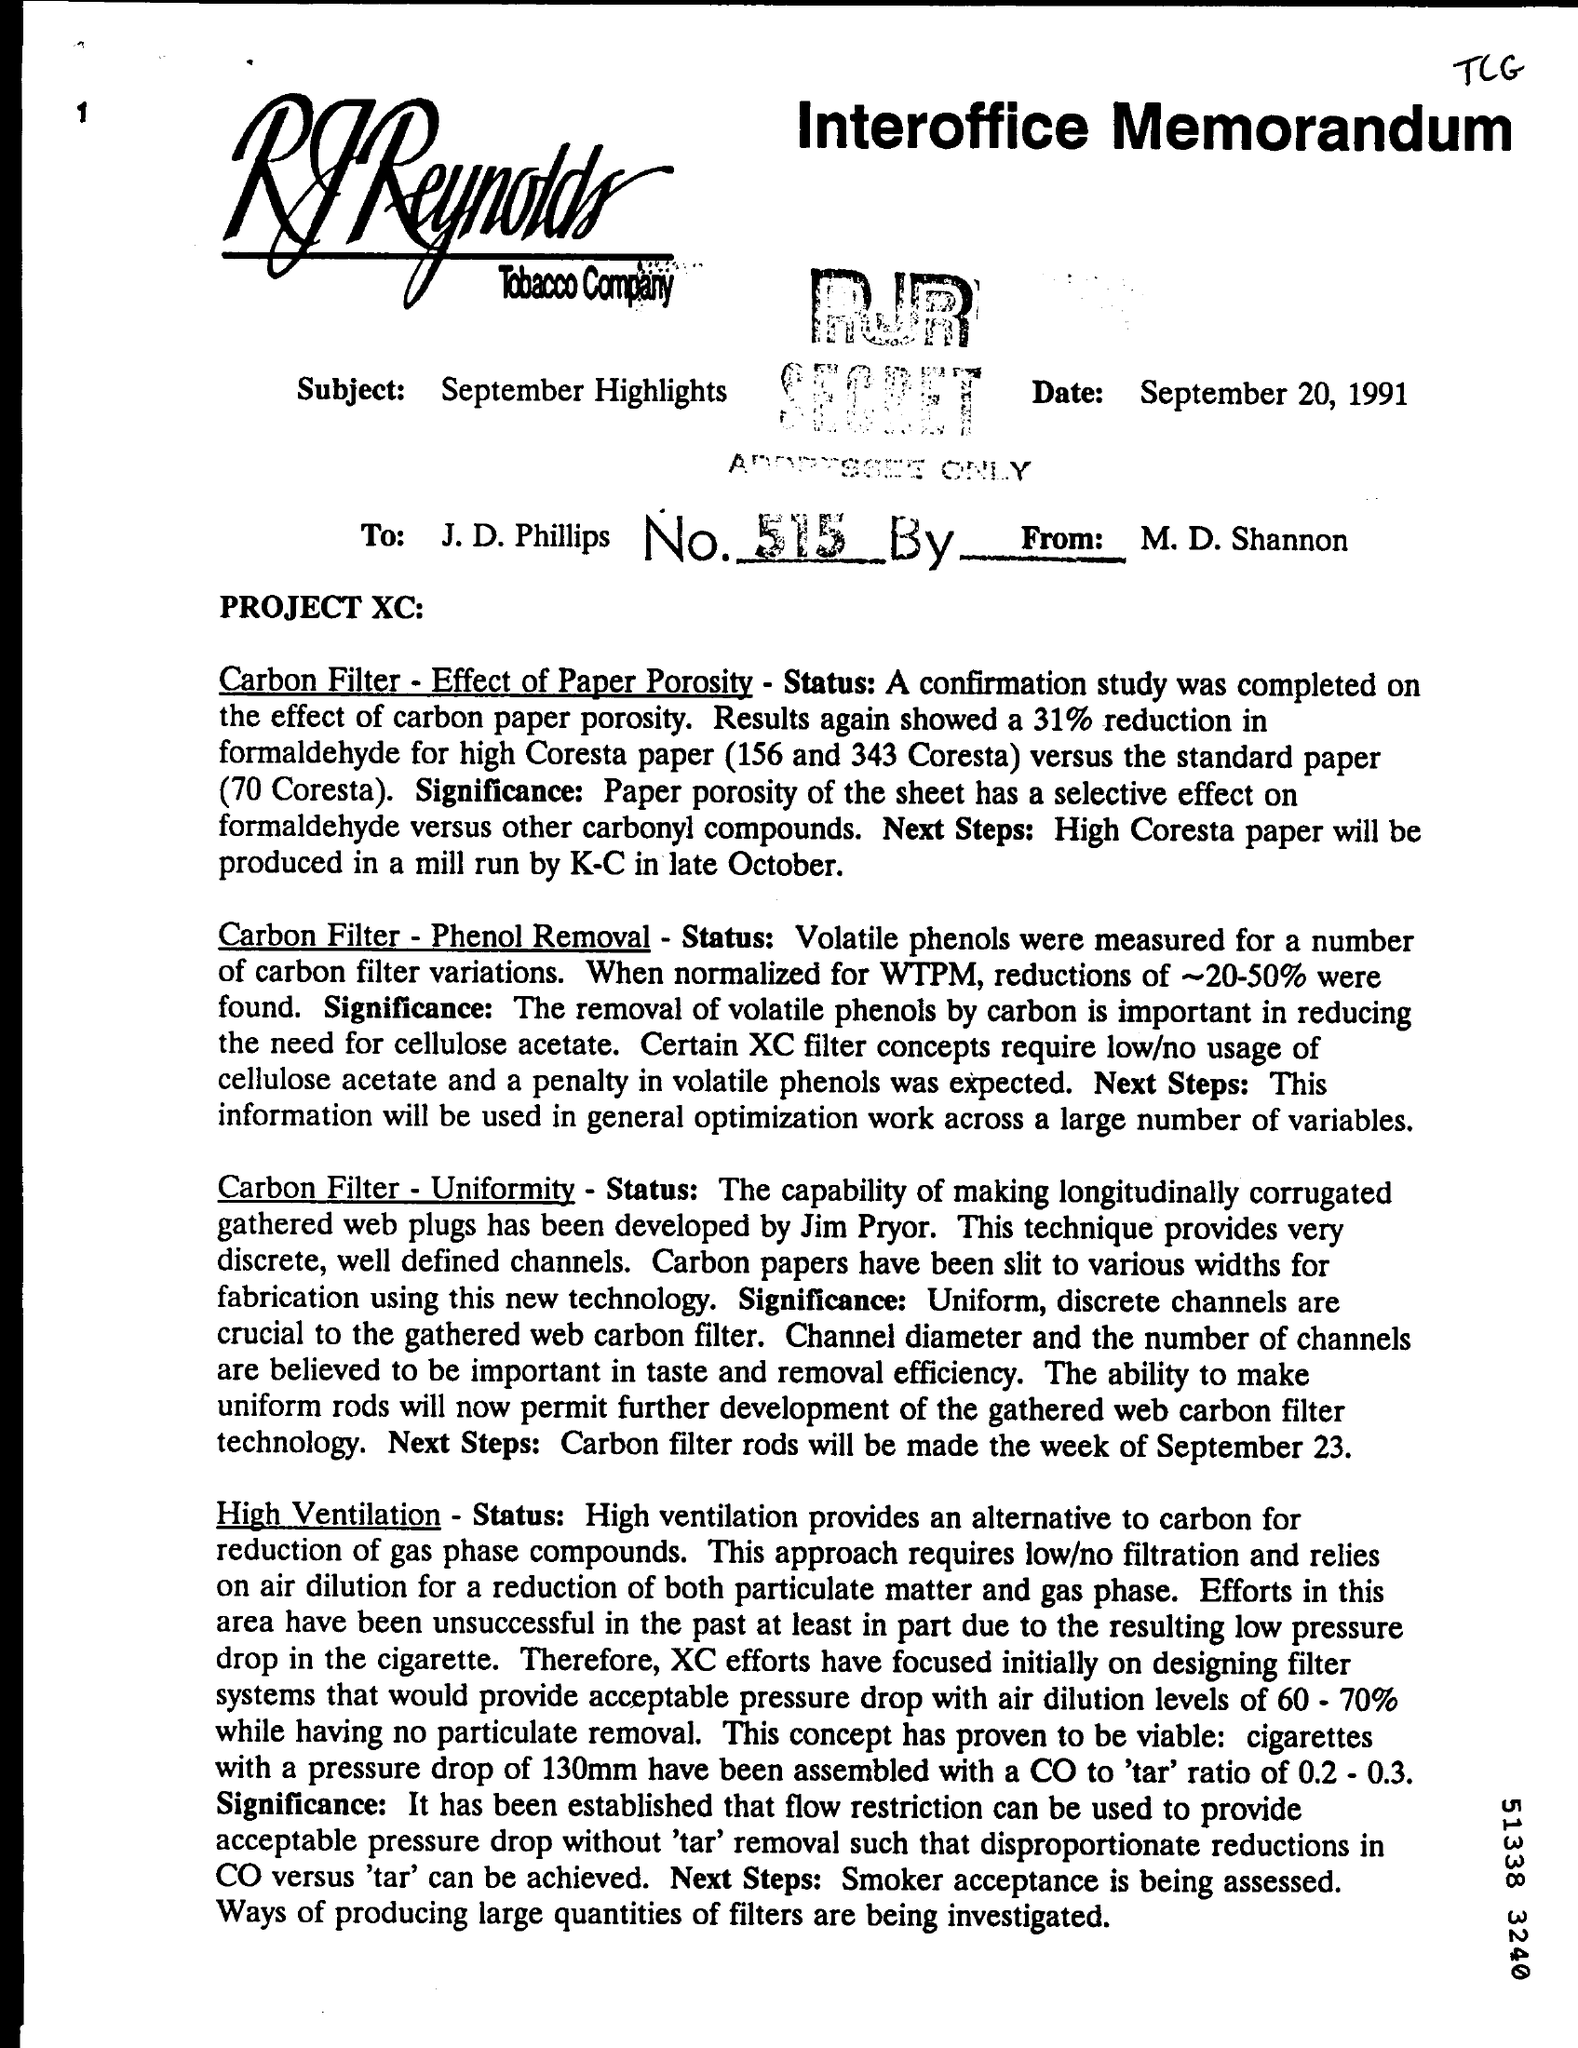Identify some key points in this picture. The document is dated September 20, 1991. The subject of the document is September highlights. 